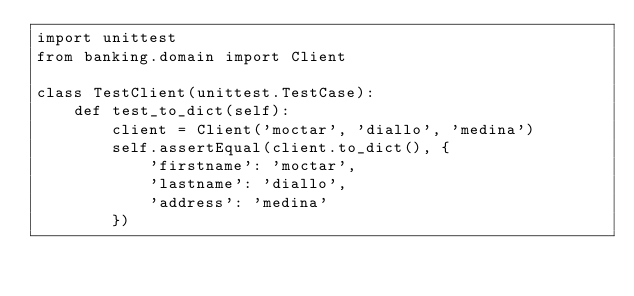Convert code to text. <code><loc_0><loc_0><loc_500><loc_500><_Python_>import unittest
from banking.domain import Client

class TestClient(unittest.TestCase):
    def test_to_dict(self):
        client = Client('moctar', 'diallo', 'medina')
        self.assertEqual(client.to_dict(), {
            'firstname': 'moctar',
            'lastname': 'diallo',
            'address': 'medina'
        })</code> 